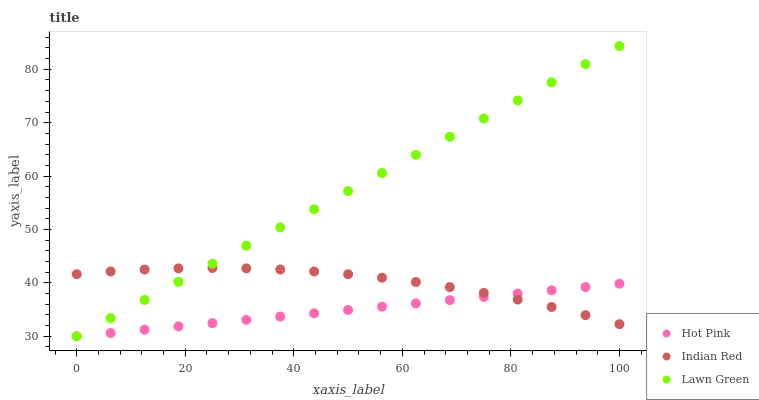Does Hot Pink have the minimum area under the curve?
Answer yes or no. Yes. Does Lawn Green have the maximum area under the curve?
Answer yes or no. Yes. Does Indian Red have the minimum area under the curve?
Answer yes or no. No. Does Indian Red have the maximum area under the curve?
Answer yes or no. No. Is Hot Pink the smoothest?
Answer yes or no. Yes. Is Indian Red the roughest?
Answer yes or no. Yes. Is Indian Red the smoothest?
Answer yes or no. No. Is Hot Pink the roughest?
Answer yes or no. No. Does Lawn Green have the lowest value?
Answer yes or no. Yes. Does Indian Red have the lowest value?
Answer yes or no. No. Does Lawn Green have the highest value?
Answer yes or no. Yes. Does Indian Red have the highest value?
Answer yes or no. No. Does Lawn Green intersect Hot Pink?
Answer yes or no. Yes. Is Lawn Green less than Hot Pink?
Answer yes or no. No. Is Lawn Green greater than Hot Pink?
Answer yes or no. No. 